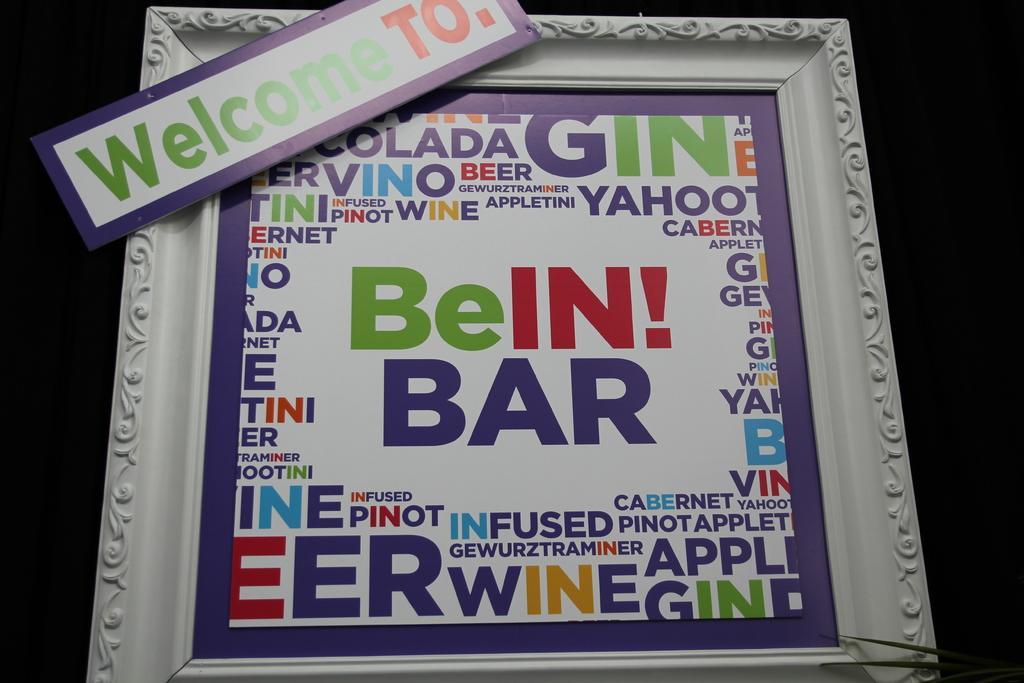<image>
Write a terse but informative summary of the picture. A bright cheery sign welcomes patrons to BeIn! bar. 